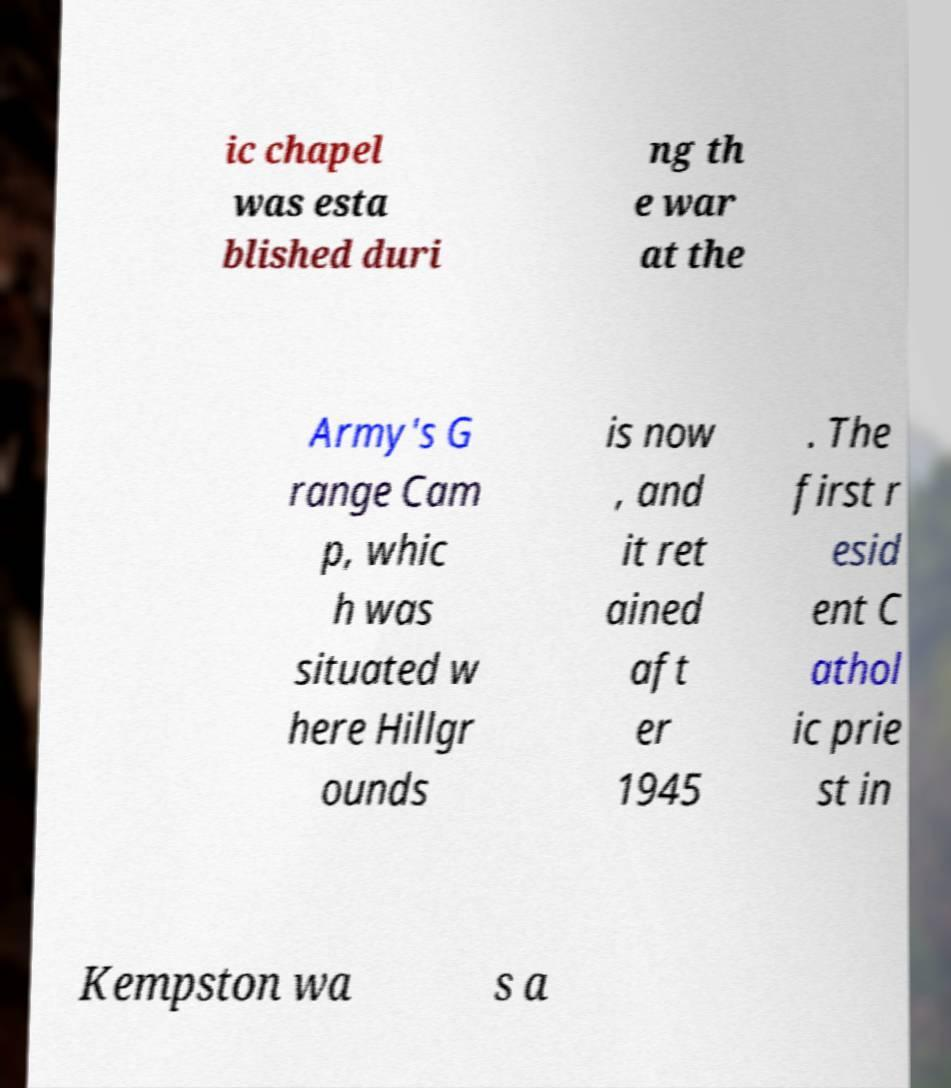Can you read and provide the text displayed in the image?This photo seems to have some interesting text. Can you extract and type it out for me? ic chapel was esta blished duri ng th e war at the Army's G range Cam p, whic h was situated w here Hillgr ounds is now , and it ret ained aft er 1945 . The first r esid ent C athol ic prie st in Kempston wa s a 